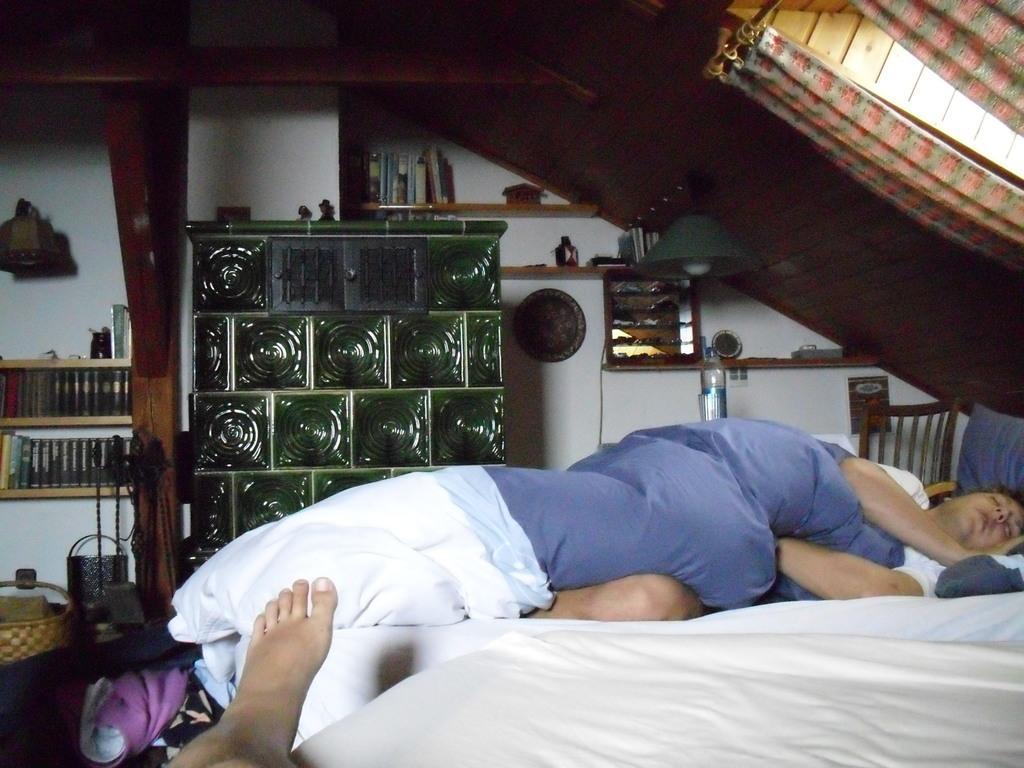How would you summarize this image in a sentence or two? In this image we can see a person is sleeping. There are few people in the image. There many books placed in the racks. There are many objects in the image. There is a lamp in the image. There are few objects on the wall. 